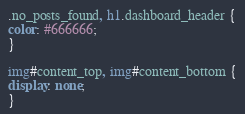Convert code to text. <code><loc_0><loc_0><loc_500><loc_500><_CSS_>
.no_posts_found, h1.dashboard_header {
color: #666666;
}

img#content_top, img#content_bottom {
display: none;
}
</code> 